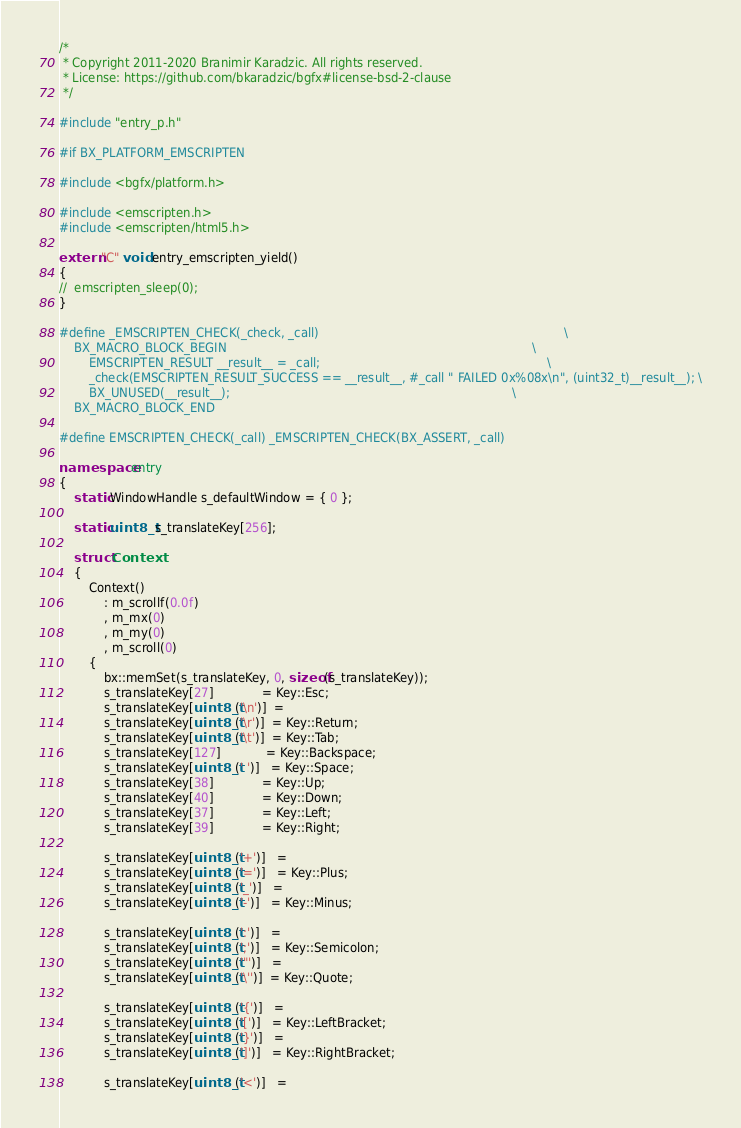<code> <loc_0><loc_0><loc_500><loc_500><_C++_>/*
 * Copyright 2011-2020 Branimir Karadzic. All rights reserved.
 * License: https://github.com/bkaradzic/bgfx#license-bsd-2-clause
 */

#include "entry_p.h"

#if BX_PLATFORM_EMSCRIPTEN

#include <bgfx/platform.h>

#include <emscripten.h>
#include <emscripten/html5.h>

extern "C" void entry_emscripten_yield()
{
//	emscripten_sleep(0);
}

#define _EMSCRIPTEN_CHECK(_check, _call)                                                                  \
	BX_MACRO_BLOCK_BEGIN                                                                                  \
		EMSCRIPTEN_RESULT __result__ = _call;                                                             \
		_check(EMSCRIPTEN_RESULT_SUCCESS == __result__, #_call " FAILED 0x%08x\n", (uint32_t)__result__); \
		BX_UNUSED(__result__);                                                                            \
	BX_MACRO_BLOCK_END

#define EMSCRIPTEN_CHECK(_call) _EMSCRIPTEN_CHECK(BX_ASSERT, _call)

namespace entry
{
	static WindowHandle s_defaultWindow = { 0 };

	static uint8_t s_translateKey[256];

	struct Context
	{
		Context()
			: m_scrollf(0.0f)
			, m_mx(0)
			, m_my(0)
			, m_scroll(0)
		{
			bx::memSet(s_translateKey, 0, sizeof(s_translateKey));
			s_translateKey[27]             = Key::Esc;
			s_translateKey[uint8_t('\n')]  =
			s_translateKey[uint8_t('\r')]  = Key::Return;
			s_translateKey[uint8_t('\t')]  = Key::Tab;
			s_translateKey[127]            = Key::Backspace;
			s_translateKey[uint8_t(' ')]   = Key::Space;
			s_translateKey[38]             = Key::Up;
			s_translateKey[40]             = Key::Down;
			s_translateKey[37]             = Key::Left;
			s_translateKey[39]             = Key::Right;

			s_translateKey[uint8_t('+')]   =
			s_translateKey[uint8_t('=')]   = Key::Plus;
			s_translateKey[uint8_t('_')]   =
			s_translateKey[uint8_t('-')]   = Key::Minus;

			s_translateKey[uint8_t(':')]   =
			s_translateKey[uint8_t(';')]   = Key::Semicolon;
			s_translateKey[uint8_t('"')]   =
			s_translateKey[uint8_t('\'')]  = Key::Quote;

			s_translateKey[uint8_t('{')]   =
			s_translateKey[uint8_t('[')]   = Key::LeftBracket;
			s_translateKey[uint8_t('}')]   =
			s_translateKey[uint8_t(']')]   = Key::RightBracket;

			s_translateKey[uint8_t('<')]   =</code> 